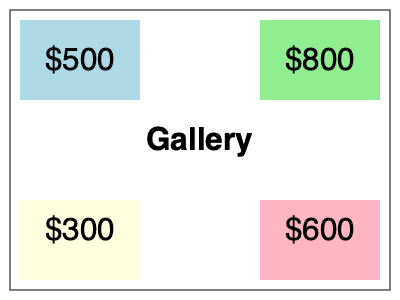As a local business owner sponsoring an art exhibition for cancer charity, you're analyzing the impact of artwork placement on donations. The gallery layout is shown above with donation amounts for each area. If you swap the positions of the artworks in the top-left and bottom-right corners, what would be the percentage increase in total donations? To solve this problem, we need to follow these steps:

1. Calculate the current total donations:
   Top-left: $500
   Top-right: $800
   Bottom-left: $300
   Bottom-right: $600
   Current total = $500 + $800 + $300 + $600 = $2200

2. Calculate the new total donations after swapping:
   Top-left: $600 (moved from bottom-right)
   Top-right: $800 (unchanged)
   Bottom-left: $300 (unchanged)
   Bottom-right: $500 (moved from top-left)
   New total = $600 + $800 + $300 + $500 = $2200

3. Calculate the difference in donations:
   Difference = New total - Current total
   Difference = $2200 - $2200 = $0

4. Calculate the percentage increase:
   Percentage increase = (Difference / Current total) × 100%
   Percentage increase = ($0 / $2200) × 100% = 0%

The swap doesn't change the total donations, resulting in a 0% increase.
Answer: 0% 